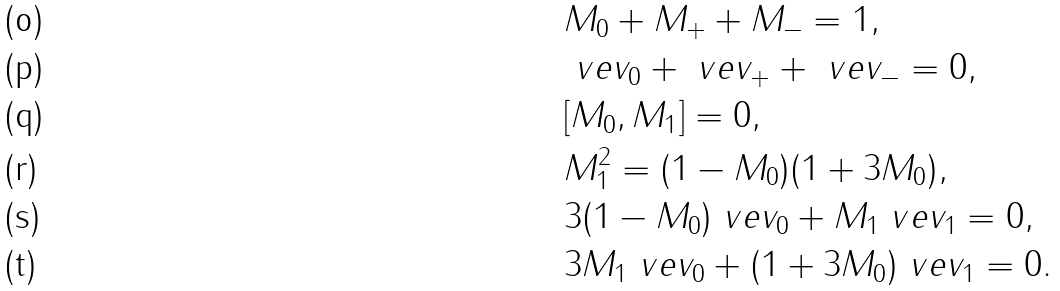<formula> <loc_0><loc_0><loc_500><loc_500>& M _ { 0 } + M _ { + } + M _ { - } = 1 , \\ & \ v e { v } _ { 0 } + \ v e { v } _ { + } + \ v e { v } _ { - } = 0 , \\ & [ M _ { 0 } , M _ { 1 } ] = 0 , \\ & M _ { 1 } ^ { 2 } = ( 1 - M _ { 0 } ) ( 1 + 3 M _ { 0 } ) , \\ & 3 ( 1 - M _ { 0 } ) \ v e { v } _ { 0 } + M _ { 1 } \ v e { v } _ { 1 } = 0 , \\ & 3 M _ { 1 } \ v e { v } _ { 0 } + ( 1 + 3 M _ { 0 } ) \ v e { v } _ { 1 } = 0 .</formula> 